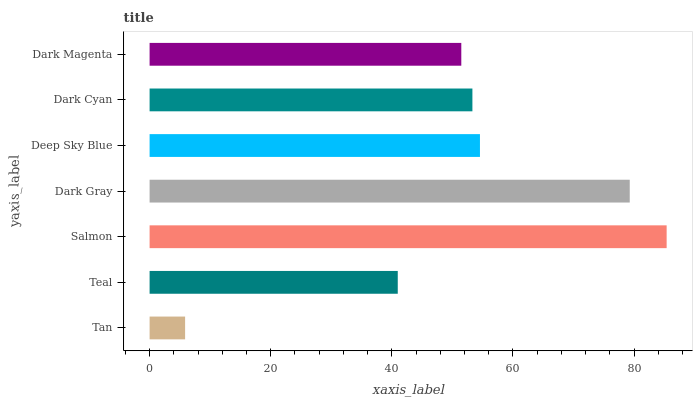Is Tan the minimum?
Answer yes or no. Yes. Is Salmon the maximum?
Answer yes or no. Yes. Is Teal the minimum?
Answer yes or no. No. Is Teal the maximum?
Answer yes or no. No. Is Teal greater than Tan?
Answer yes or no. Yes. Is Tan less than Teal?
Answer yes or no. Yes. Is Tan greater than Teal?
Answer yes or no. No. Is Teal less than Tan?
Answer yes or no. No. Is Dark Cyan the high median?
Answer yes or no. Yes. Is Dark Cyan the low median?
Answer yes or no. Yes. Is Deep Sky Blue the high median?
Answer yes or no. No. Is Deep Sky Blue the low median?
Answer yes or no. No. 